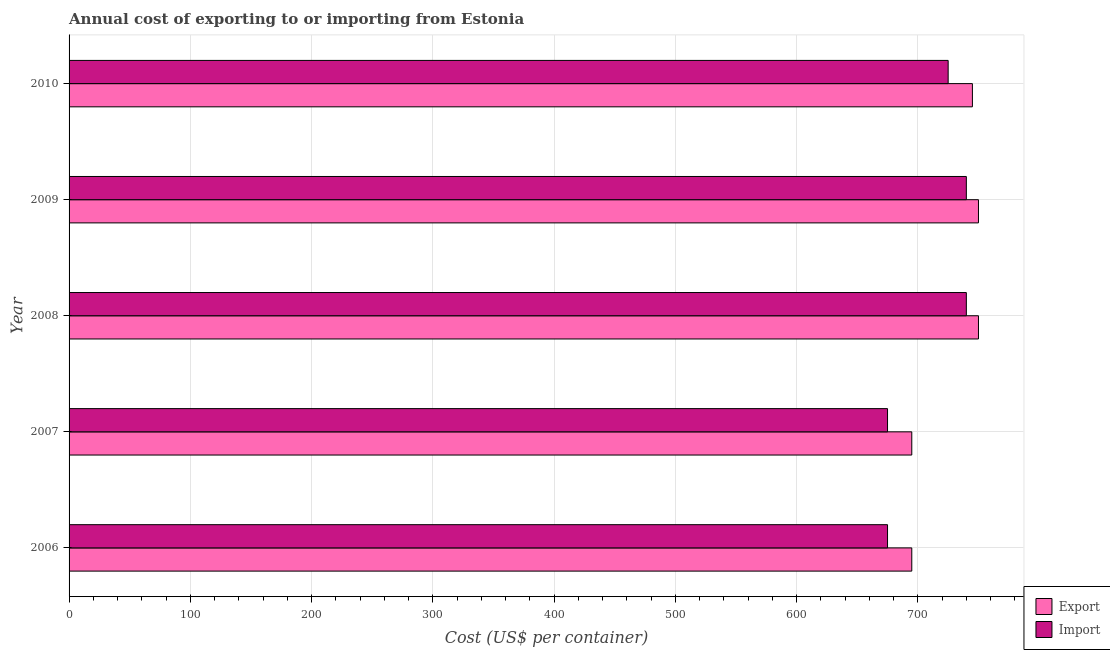Are the number of bars per tick equal to the number of legend labels?
Offer a very short reply. Yes. How many bars are there on the 3rd tick from the top?
Offer a terse response. 2. How many bars are there on the 3rd tick from the bottom?
Your answer should be compact. 2. What is the label of the 5th group of bars from the top?
Your response must be concise. 2006. What is the import cost in 2008?
Your answer should be compact. 740. Across all years, what is the maximum export cost?
Your answer should be compact. 750. Across all years, what is the minimum import cost?
Keep it short and to the point. 675. What is the total export cost in the graph?
Your answer should be compact. 3635. What is the difference between the export cost in 2006 and that in 2009?
Your response must be concise. -55. What is the difference between the export cost in 2006 and the import cost in 2007?
Your answer should be very brief. 20. What is the average import cost per year?
Provide a short and direct response. 711. In the year 2009, what is the difference between the import cost and export cost?
Your answer should be compact. -10. Is the import cost in 2006 less than that in 2010?
Give a very brief answer. Yes. Is the difference between the export cost in 2006 and 2007 greater than the difference between the import cost in 2006 and 2007?
Offer a terse response. No. What is the difference between the highest and the lowest export cost?
Offer a very short reply. 55. In how many years, is the export cost greater than the average export cost taken over all years?
Your answer should be compact. 3. Is the sum of the import cost in 2008 and 2010 greater than the maximum export cost across all years?
Provide a short and direct response. Yes. What does the 1st bar from the top in 2006 represents?
Offer a terse response. Import. What does the 2nd bar from the bottom in 2006 represents?
Ensure brevity in your answer.  Import. How many bars are there?
Ensure brevity in your answer.  10. Are all the bars in the graph horizontal?
Your answer should be very brief. Yes. What is the difference between two consecutive major ticks on the X-axis?
Offer a very short reply. 100. Where does the legend appear in the graph?
Give a very brief answer. Bottom right. How are the legend labels stacked?
Your response must be concise. Vertical. What is the title of the graph?
Offer a very short reply. Annual cost of exporting to or importing from Estonia. Does "Primary completion rate" appear as one of the legend labels in the graph?
Offer a terse response. No. What is the label or title of the X-axis?
Ensure brevity in your answer.  Cost (US$ per container). What is the Cost (US$ per container) of Export in 2006?
Offer a very short reply. 695. What is the Cost (US$ per container) of Import in 2006?
Keep it short and to the point. 675. What is the Cost (US$ per container) of Export in 2007?
Keep it short and to the point. 695. What is the Cost (US$ per container) in Import in 2007?
Offer a terse response. 675. What is the Cost (US$ per container) in Export in 2008?
Give a very brief answer. 750. What is the Cost (US$ per container) in Import in 2008?
Offer a terse response. 740. What is the Cost (US$ per container) of Export in 2009?
Your response must be concise. 750. What is the Cost (US$ per container) of Import in 2009?
Offer a very short reply. 740. What is the Cost (US$ per container) in Export in 2010?
Give a very brief answer. 745. What is the Cost (US$ per container) of Import in 2010?
Ensure brevity in your answer.  725. Across all years, what is the maximum Cost (US$ per container) in Export?
Provide a short and direct response. 750. Across all years, what is the maximum Cost (US$ per container) of Import?
Ensure brevity in your answer.  740. Across all years, what is the minimum Cost (US$ per container) of Export?
Offer a terse response. 695. Across all years, what is the minimum Cost (US$ per container) of Import?
Your answer should be compact. 675. What is the total Cost (US$ per container) in Export in the graph?
Make the answer very short. 3635. What is the total Cost (US$ per container) of Import in the graph?
Ensure brevity in your answer.  3555. What is the difference between the Cost (US$ per container) of Import in 2006 and that in 2007?
Ensure brevity in your answer.  0. What is the difference between the Cost (US$ per container) of Export in 2006 and that in 2008?
Offer a terse response. -55. What is the difference between the Cost (US$ per container) in Import in 2006 and that in 2008?
Make the answer very short. -65. What is the difference between the Cost (US$ per container) of Export in 2006 and that in 2009?
Your answer should be compact. -55. What is the difference between the Cost (US$ per container) of Import in 2006 and that in 2009?
Provide a succinct answer. -65. What is the difference between the Cost (US$ per container) in Import in 2006 and that in 2010?
Provide a succinct answer. -50. What is the difference between the Cost (US$ per container) in Export in 2007 and that in 2008?
Offer a terse response. -55. What is the difference between the Cost (US$ per container) in Import in 2007 and that in 2008?
Offer a very short reply. -65. What is the difference between the Cost (US$ per container) in Export in 2007 and that in 2009?
Your answer should be compact. -55. What is the difference between the Cost (US$ per container) of Import in 2007 and that in 2009?
Your response must be concise. -65. What is the difference between the Cost (US$ per container) in Export in 2007 and that in 2010?
Give a very brief answer. -50. What is the difference between the Cost (US$ per container) of Import in 2007 and that in 2010?
Provide a short and direct response. -50. What is the difference between the Cost (US$ per container) in Export in 2008 and that in 2010?
Make the answer very short. 5. What is the difference between the Cost (US$ per container) in Export in 2006 and the Cost (US$ per container) in Import in 2008?
Your response must be concise. -45. What is the difference between the Cost (US$ per container) of Export in 2006 and the Cost (US$ per container) of Import in 2009?
Provide a succinct answer. -45. What is the difference between the Cost (US$ per container) in Export in 2007 and the Cost (US$ per container) in Import in 2008?
Ensure brevity in your answer.  -45. What is the difference between the Cost (US$ per container) in Export in 2007 and the Cost (US$ per container) in Import in 2009?
Offer a very short reply. -45. What is the difference between the Cost (US$ per container) of Export in 2008 and the Cost (US$ per container) of Import in 2009?
Your answer should be compact. 10. What is the average Cost (US$ per container) in Export per year?
Provide a succinct answer. 727. What is the average Cost (US$ per container) in Import per year?
Provide a short and direct response. 711. In the year 2007, what is the difference between the Cost (US$ per container) in Export and Cost (US$ per container) in Import?
Your response must be concise. 20. What is the ratio of the Cost (US$ per container) of Export in 2006 to that in 2007?
Offer a terse response. 1. What is the ratio of the Cost (US$ per container) of Export in 2006 to that in 2008?
Your answer should be compact. 0.93. What is the ratio of the Cost (US$ per container) in Import in 2006 to that in 2008?
Offer a very short reply. 0.91. What is the ratio of the Cost (US$ per container) of Export in 2006 to that in 2009?
Ensure brevity in your answer.  0.93. What is the ratio of the Cost (US$ per container) of Import in 2006 to that in 2009?
Provide a short and direct response. 0.91. What is the ratio of the Cost (US$ per container) of Export in 2006 to that in 2010?
Provide a succinct answer. 0.93. What is the ratio of the Cost (US$ per container) in Export in 2007 to that in 2008?
Ensure brevity in your answer.  0.93. What is the ratio of the Cost (US$ per container) of Import in 2007 to that in 2008?
Your response must be concise. 0.91. What is the ratio of the Cost (US$ per container) of Export in 2007 to that in 2009?
Provide a short and direct response. 0.93. What is the ratio of the Cost (US$ per container) of Import in 2007 to that in 2009?
Provide a short and direct response. 0.91. What is the ratio of the Cost (US$ per container) in Export in 2007 to that in 2010?
Ensure brevity in your answer.  0.93. What is the ratio of the Cost (US$ per container) in Import in 2007 to that in 2010?
Keep it short and to the point. 0.93. What is the ratio of the Cost (US$ per container) in Export in 2008 to that in 2010?
Your answer should be very brief. 1.01. What is the ratio of the Cost (US$ per container) in Import in 2008 to that in 2010?
Offer a very short reply. 1.02. What is the ratio of the Cost (US$ per container) of Export in 2009 to that in 2010?
Keep it short and to the point. 1.01. What is the ratio of the Cost (US$ per container) of Import in 2009 to that in 2010?
Offer a very short reply. 1.02. What is the difference between the highest and the second highest Cost (US$ per container) in Export?
Provide a short and direct response. 0. What is the difference between the highest and the second highest Cost (US$ per container) in Import?
Offer a very short reply. 0. What is the difference between the highest and the lowest Cost (US$ per container) of Export?
Provide a short and direct response. 55. 